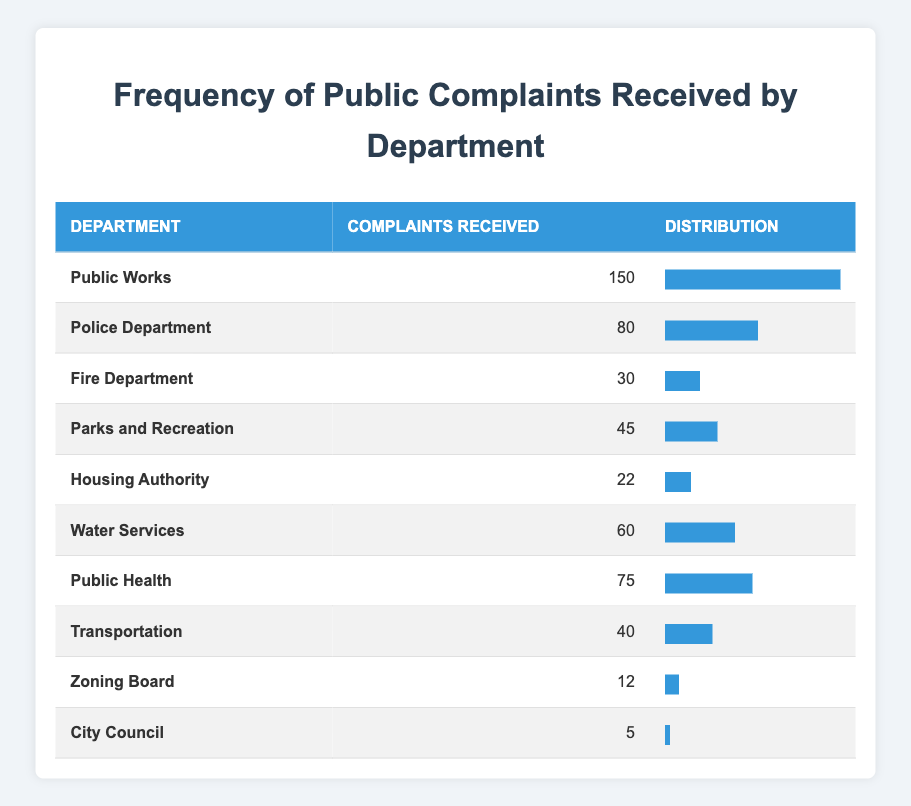What department received the highest number of complaints? Looking at the table, Public Works has the highest count of complaints received at 150.
Answer: Public Works How many complaints did the Fire Department receive? The Fire Department's row indicates that it received 30 complaints.
Answer: 30 What is the total number of complaints received by the Police Department and Water Services combined? The Police Department received 80 complaints and Water Services received 60 complaints. Adding these figures together gives 80 + 60 = 140.
Answer: 140 Is it true that the City Council received more complaints than the Zoning Board? The City Council received 5 complaints, whereas the Zoning Board received 12 complaints. Since 5 is less than 12, this statement is false.
Answer: No What is the average number of complaints received across all departments? To find the average, we sum all complaints: 150 + 80 + 30 + 45 + 22 + 60 + 75 + 40 + 12 + 5 = 474. There are 10 departments, so the average is 474 / 10 = 47.4.
Answer: 47.4 How many departments received more than 50 complaints? The departments that received more than 50 complaints are Public Works (150), Police Department (80), and Water Services (60). That totals three departments exceeding 50 complaints.
Answer: 3 What percentage of total complaints came from the Public Health department? The Public Health department received 75 complaints, contributing to a total of 474 complaints. To find the percentage, we calculate (75 / 474) * 100, which equals approximately 15.8%.
Answer: 15.8% Which department had the lowest number of complaints? The data shows that City Council received the lowest count of complaints, with only 5 complaints registered.
Answer: City Council What is the difference in complaints received between the Public Works department and the Housing Authority? Public Works received 150 complaints while Housing Authority received 22. The difference is 150 - 22 = 128.
Answer: 128 